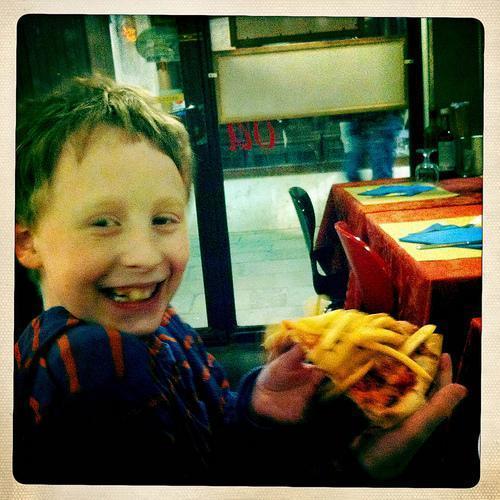How many red chairs are there?
Give a very brief answer. 1. 